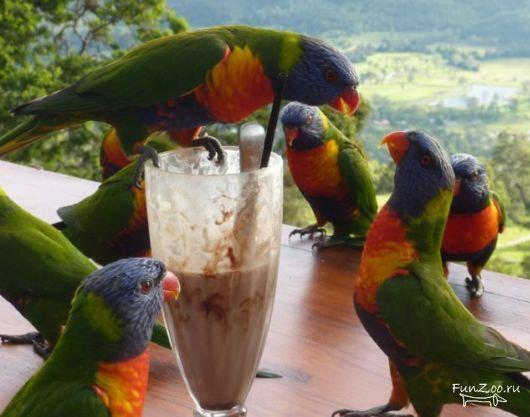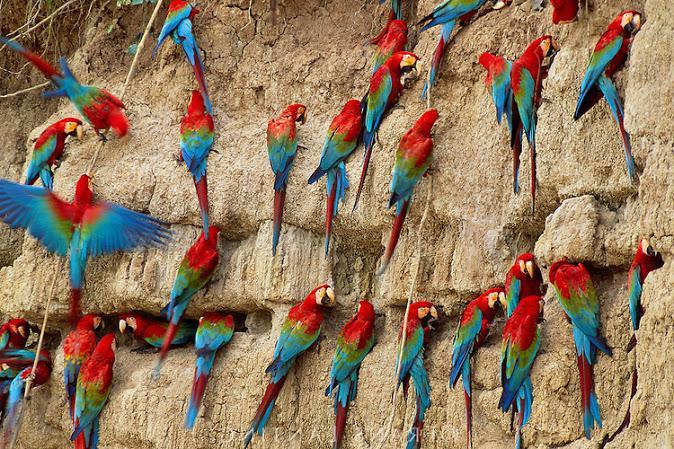The first image is the image on the left, the second image is the image on the right. Given the left and right images, does the statement "there are many birds perched on the side of a cliff in one of the images." hold true? Answer yes or no. Yes. The first image is the image on the left, the second image is the image on the right. Given the left and right images, does the statement "In one image, parrots are shown with a tall ice cream dessert." hold true? Answer yes or no. Yes. 